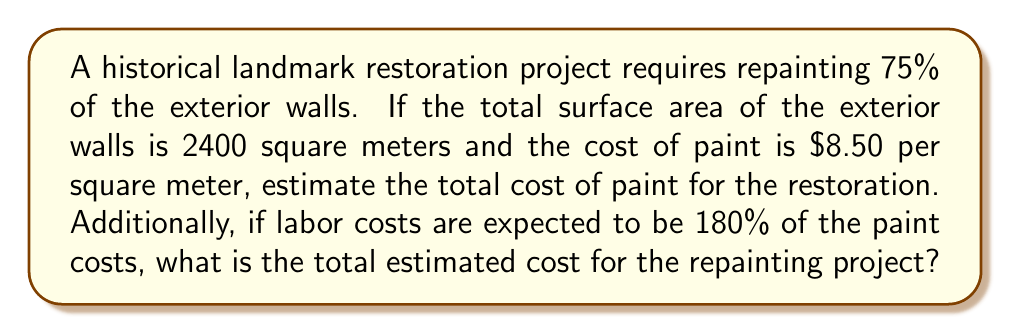Give your solution to this math problem. Let's break this problem down into steps:

1. Calculate the area to be painted:
   * Total surface area = 2400 square meters
   * Percentage to be painted = 75% = 0.75
   * Area to be painted = $2400 \times 0.75 = 1800$ square meters

2. Calculate the cost of paint:
   * Cost per square meter = $8.50
   * Total paint cost = $1800 \times $8.50 = $15,300

3. Calculate the labor cost:
   * Labor cost is 180% of paint cost
   * Labor cost = $15,300 \times 1.80 = $27,540

4. Calculate the total project cost:
   * Total cost = Paint cost + Labor cost
   * Total cost = $15,300 + $27,540 = $42,840

We can express this mathematically as:

$$\text{Total Cost} = (A \times p \times c) + (A \times p \times c \times l)$$

Where:
$A$ = Total surface area
$p$ = Proportion to be painted
$c$ = Cost of paint per square meter
$l$ = Labor cost as a proportion of paint cost

Substituting our values:

$$\text{Total Cost} = (2400 \times 0.75 \times 8.50) + (2400 \times 0.75 \times 8.50 \times 1.80) = 15,300 + 27,540 = 42,840$$
Answer: The total estimated cost for the repainting project is $42,840. 